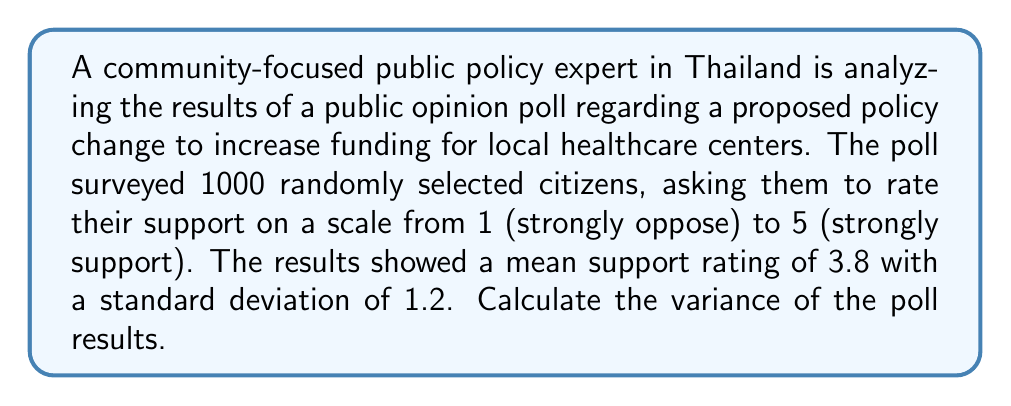Teach me how to tackle this problem. To calculate the variance, we'll follow these steps:

1. Recall the formula for variance:
   $$\text{Variance} = \sigma^2 = E[(X - \mu)^2]$$
   where $\sigma^2$ is the variance, $X$ is the random variable, and $\mu$ is the mean.

2. We're given the standard deviation $\sigma = 1.2$.

3. The variance is the square of the standard deviation:
   $$\text{Variance} = \sigma^2 = (1.2)^2$$

4. Calculate:
   $$\text{Variance} = 1.2 \times 1.2 = 1.44$$

This variance indicates the spread of opinions in the poll. A higher variance suggests more diverse opinions among Thai citizens regarding the proposed healthcare funding policy.
Answer: $1.44$ 